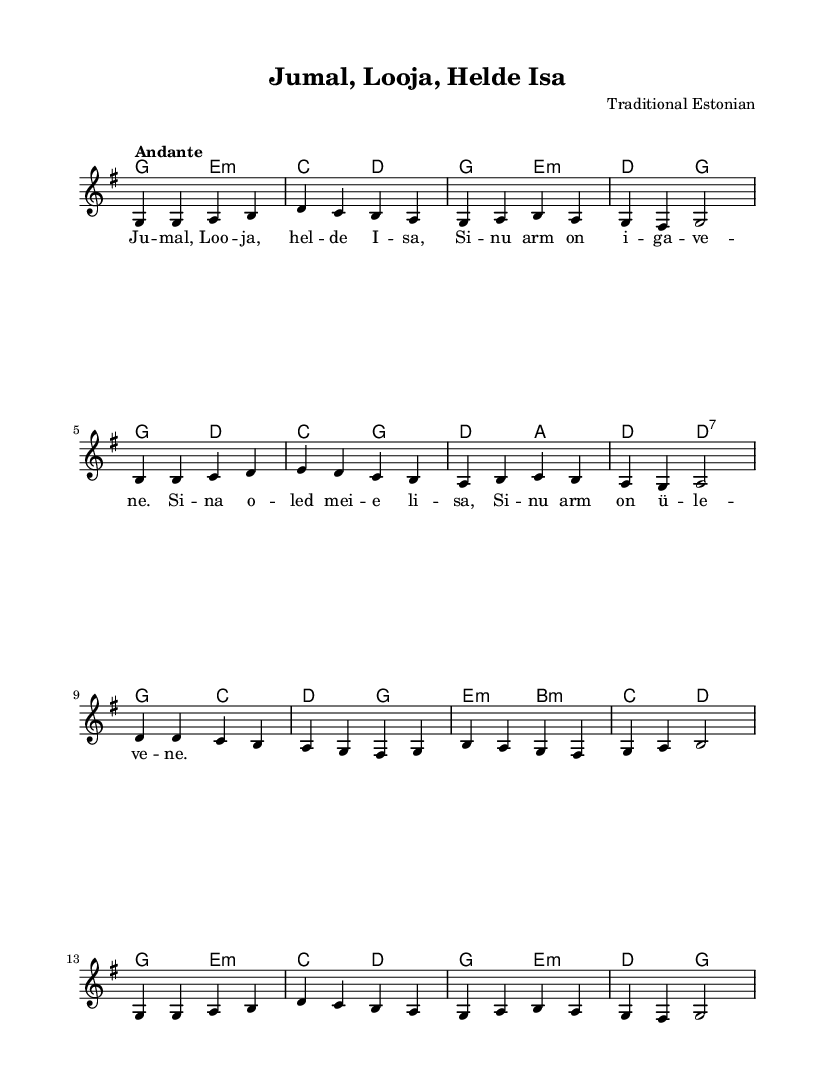What is the key signature of this music? The key signature is indicated by the sharps or flats at the beginning of the staff. In this case, there are no sharps or flats shown, confirming the key is G major.
Answer: G major What is the time signature of this music? The time signature is shown at the beginning as a fraction. Here, it is 4 over 4, which means there are four beats in a measure and that the quarter note gets one beat.
Answer: 4/4 What is the tempo marking for this piece? The tempo marking is typically indicated above the staff. Here, it is marked as "Andante," which indicates a moderately slow tempo.
Answer: Andante How many measures are there in the melody? To find the number of measures, you would count the number of vertical bars in the melody section. There are 16 vertical bars separating the measures, indicating a total of 16 measures.
Answer: 16 What is the first line of lyrics for this hymn? The lyrics are positioned below the melody notes and the first line is indicated by the first set of syllables in the lyric mode section. The first line is "Jumal, Looja, helde Isa."
Answer: Jumal, Looja, helde Isa Which chord follows the G major chord in this piece? Chords are indicated above the staff. The first chord that follows after G major is E minor, as indicated in the harmonies section.
Answer: E minor What is the type of hymn this piece represents? This is a traditional Estonian Lutheran hymn, which is specified in the header information stating it is a "Lutheran hymn."
Answer: Lutheran hymn 